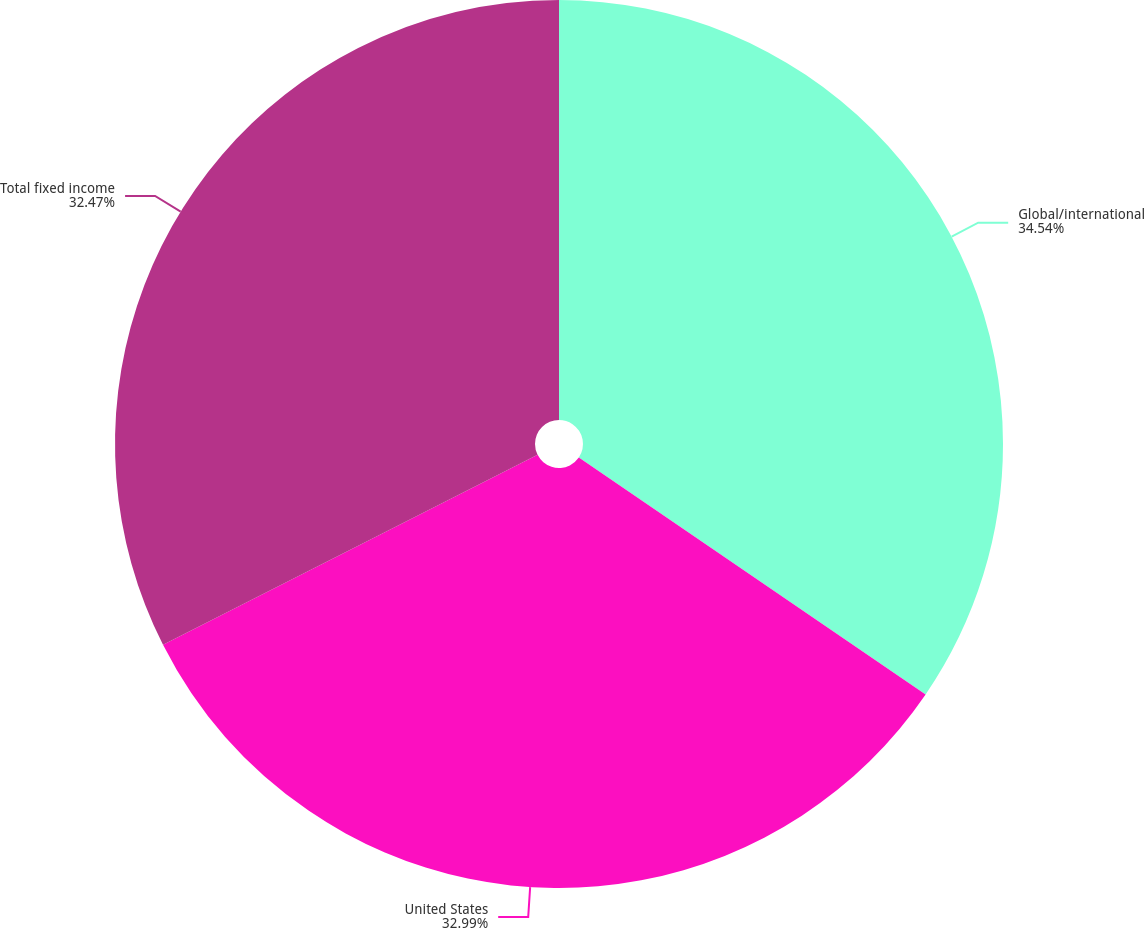Convert chart. <chart><loc_0><loc_0><loc_500><loc_500><pie_chart><fcel>Global/international<fcel>United States<fcel>Total fixed income<nl><fcel>34.54%<fcel>32.99%<fcel>32.47%<nl></chart> 